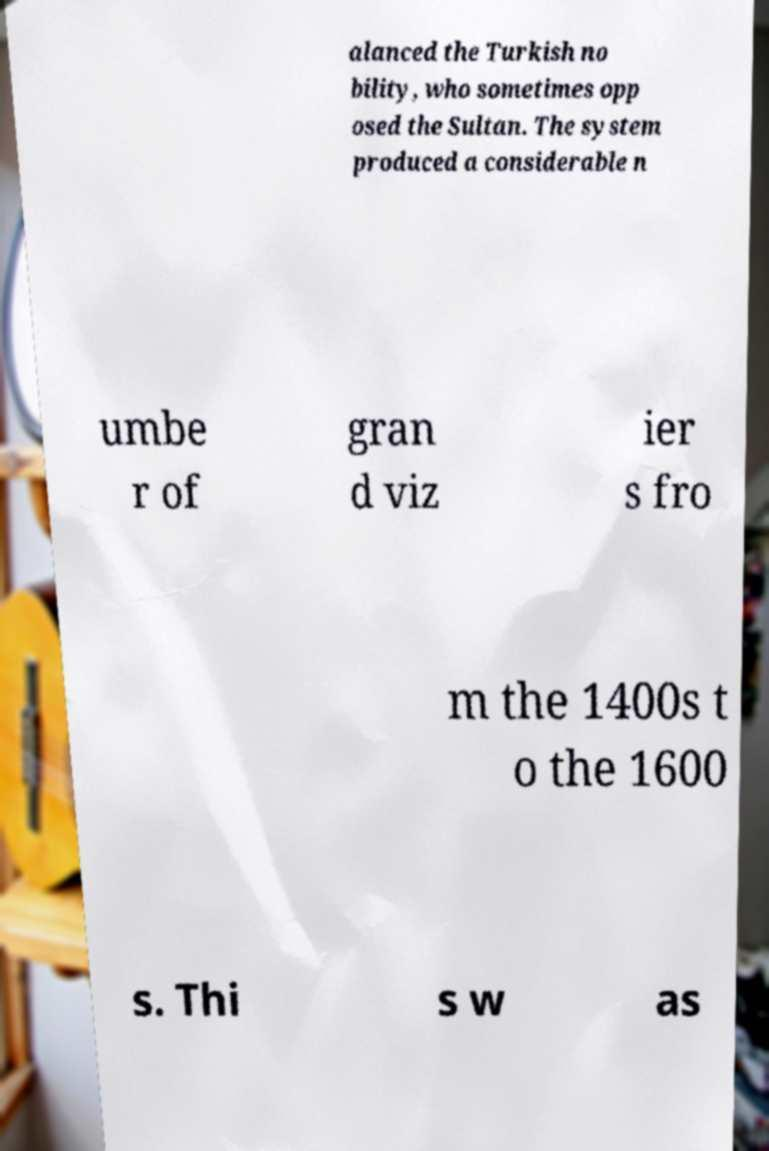Could you assist in decoding the text presented in this image and type it out clearly? alanced the Turkish no bility, who sometimes opp osed the Sultan. The system produced a considerable n umbe r of gran d viz ier s fro m the 1400s t o the 1600 s. Thi s w as 